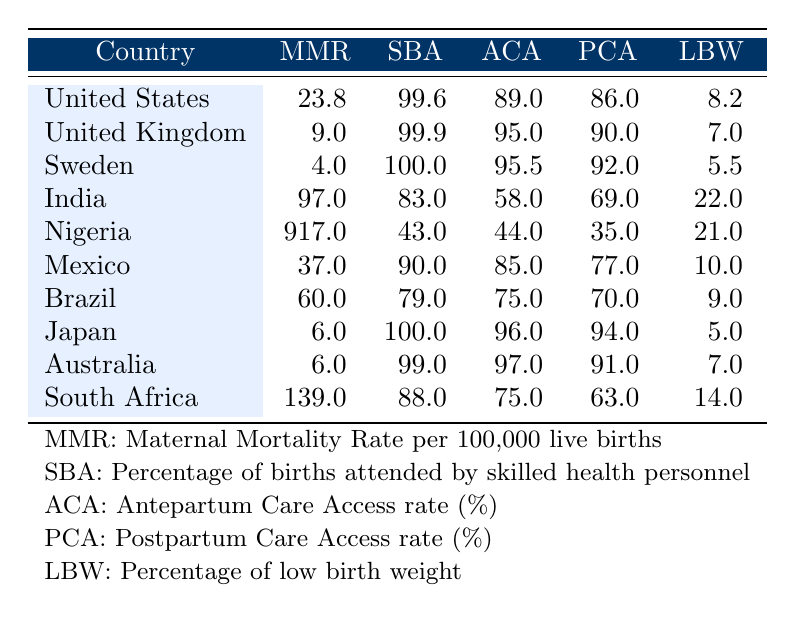What is the maternal mortality rate in Sweden? The table shows Sweden has a maternal mortality rate per 100,000 live births of 4.0, which is listed directly in the row for Sweden.
Answer: 4.0 Which country has the highest percentage of births attended by skilled health personnel? According to the table, Sweden has the highest percentage of births attended by skilled health personnel at 100.0%, which is indicated in the corresponding row.
Answer: Sweden What is the difference in maternal mortality rates between Nigeria and the United Kingdom? From the table, Nigeria's maternal mortality rate is 917.0 and the United Kingdom's is 9.0. The difference is calculated as 917.0 - 9.0 = 908.0.
Answer: 908.0 Is the postpartum care access rate in Australia higher than that in India? The table indicates that Australia has a postpartum care access rate of 91.0% while India has 69.0%. Since 91.0 is greater than 69.0, the statement is true.
Answer: Yes What is the average percentage of low birth weight across the provided countries? To find the average, we sum the percentage of low birth weight: (8.2 + 7.0 + 5.5 + 22.0 + 21.0 + 10.0 + 9.0 + 5.0 + 7.0 + 14.0) = 104.7. With 10 countries, the average is 104.7 / 10 = 10.47.
Answer: 10.47 Which country has a percentage of low birth weight greater than 20%? The table shows that India (22.0) and Nigeria (21.0) have a percentage of low birth weight greater than 20%, while others do not.
Answer: India and Nigeria What are the maternal mortality rates for Brazil and Mexico? The table lists Brazil's maternal mortality rate as 60.0 and Mexico's as 37.0. These values are found directly in their respective rows in the table.
Answer: Brazil: 60.0, Mexico: 37.0 Does South Africa have access rates for antepartum care and postpartum care lower than 70%? The antepartum care access rate in South Africa is 75.0% and postpartum care access rate is 63.0%. Since the postpartum care is lower than 70% and antepartum care is not, the statement is partially true.
Answer: No Which country has the highest maternal mortality rate? By examining the table, Nigeria has the highest maternal mortality rate at 917.0, clearly indicated as the highest value in that column.
Answer: Nigeria 